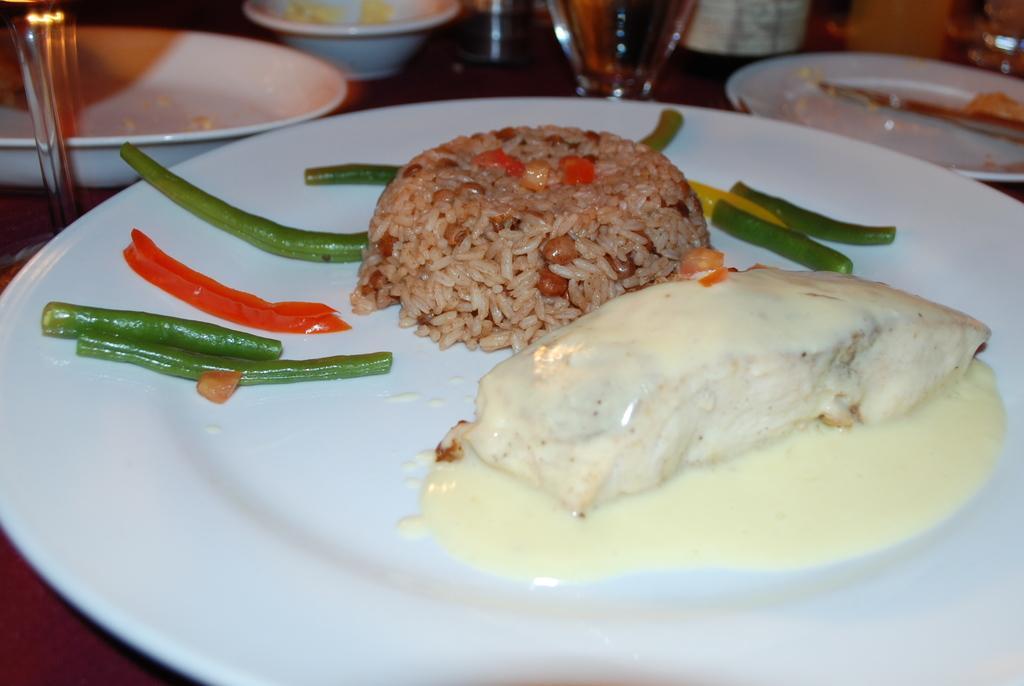How would you summarize this image in a sentence or two? In this image there is a table having plates, bowls, glasses and few objects. Bottom of the image there is a plate having vegetable slices and some food. Right side there is a plate having a knife. 